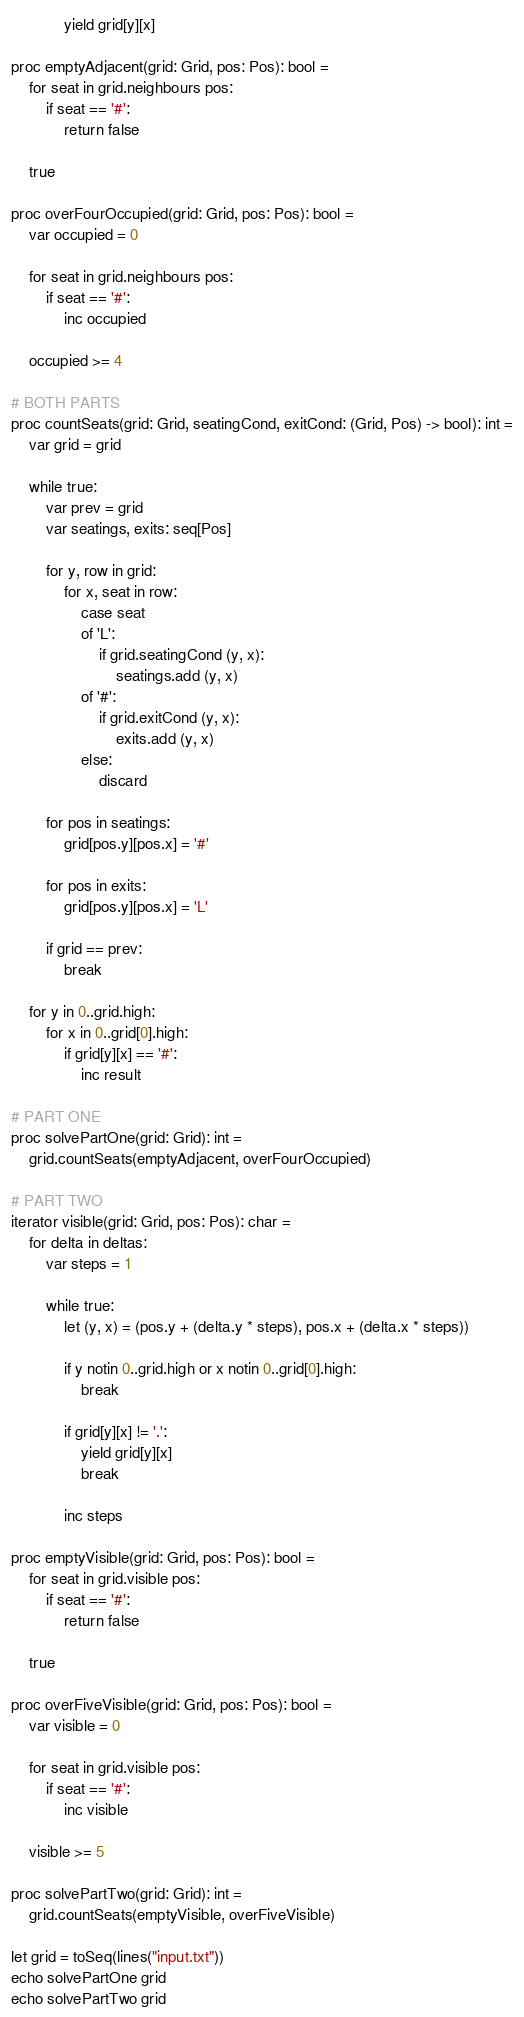Convert code to text. <code><loc_0><loc_0><loc_500><loc_500><_Nim_>            yield grid[y][x]

proc emptyAdjacent(grid: Grid, pos: Pos): bool =
    for seat in grid.neighbours pos:
        if seat == '#':
            return false

    true

proc overFourOccupied(grid: Grid, pos: Pos): bool =
    var occupied = 0

    for seat in grid.neighbours pos:
        if seat == '#':
            inc occupied

    occupied >= 4

# BOTH PARTS
proc countSeats(grid: Grid, seatingCond, exitCond: (Grid, Pos) -> bool): int =
    var grid = grid

    while true:
        var prev = grid
        var seatings, exits: seq[Pos]

        for y, row in grid:
            for x, seat in row:
                case seat
                of 'L':
                    if grid.seatingCond (y, x):
                        seatings.add (y, x)
                of '#':
                    if grid.exitCond (y, x):
                        exits.add (y, x)
                else:
                    discard

        for pos in seatings:
            grid[pos.y][pos.x] = '#'

        for pos in exits:
            grid[pos.y][pos.x] = 'L'

        if grid == prev:
            break

    for y in 0..grid.high:
        for x in 0..grid[0].high:
            if grid[y][x] == '#':
                inc result

# PART ONE
proc solvePartOne(grid: Grid): int =
    grid.countSeats(emptyAdjacent, overFourOccupied)

# PART TWO
iterator visible(grid: Grid, pos: Pos): char =
    for delta in deltas:
        var steps = 1

        while true:
            let (y, x) = (pos.y + (delta.y * steps), pos.x + (delta.x * steps))

            if y notin 0..grid.high or x notin 0..grid[0].high:
                break

            if grid[y][x] != '.':
                yield grid[y][x]
                break

            inc steps

proc emptyVisible(grid: Grid, pos: Pos): bool =
    for seat in grid.visible pos:
        if seat == '#':
            return false

    true

proc overFiveVisible(grid: Grid, pos: Pos): bool =
    var visible = 0

    for seat in grid.visible pos:
        if seat == '#':
            inc visible

    visible >= 5

proc solvePartTwo(grid: Grid): int =
    grid.countSeats(emptyVisible, overFiveVisible)

let grid = toSeq(lines("input.txt"))
echo solvePartOne grid
echo solvePartTwo grid
</code> 